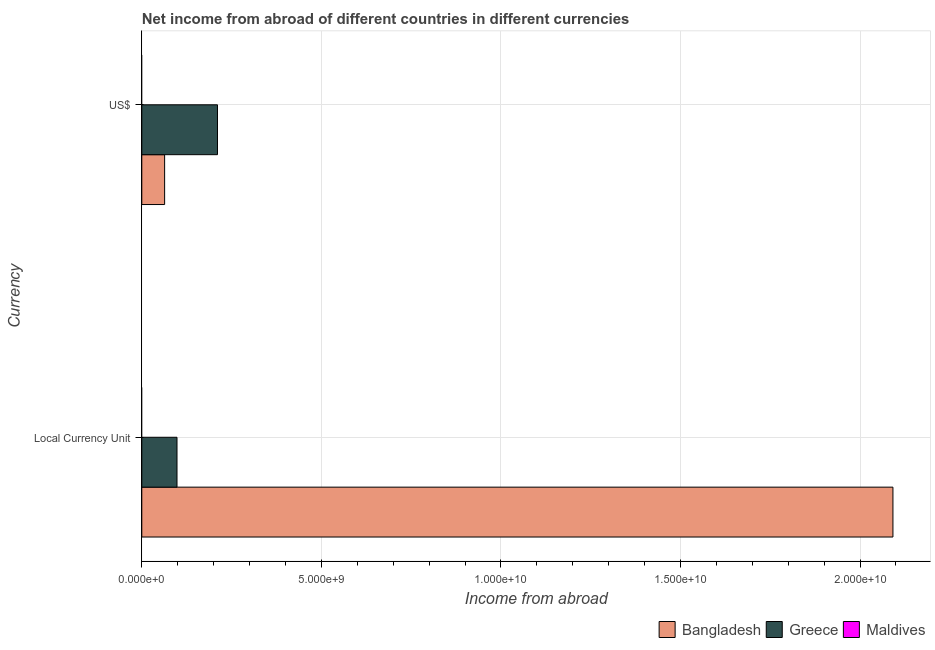How many groups of bars are there?
Your answer should be very brief. 2. Are the number of bars per tick equal to the number of legend labels?
Your response must be concise. No. Are the number of bars on each tick of the Y-axis equal?
Offer a terse response. Yes. How many bars are there on the 2nd tick from the bottom?
Ensure brevity in your answer.  2. What is the label of the 2nd group of bars from the top?
Provide a short and direct response. Local Currency Unit. What is the income from abroad in us$ in Bangladesh?
Make the answer very short. 6.36e+08. Across all countries, what is the maximum income from abroad in constant 2005 us$?
Your response must be concise. 2.09e+1. In which country was the income from abroad in us$ maximum?
Offer a terse response. Greece. What is the total income from abroad in constant 2005 us$ in the graph?
Your response must be concise. 2.19e+1. What is the difference between the income from abroad in constant 2005 us$ in Greece and that in Bangladesh?
Your answer should be compact. -1.99e+1. What is the difference between the income from abroad in constant 2005 us$ in Maldives and the income from abroad in us$ in Greece?
Ensure brevity in your answer.  -2.11e+09. What is the average income from abroad in constant 2005 us$ per country?
Provide a succinct answer. 7.30e+09. What is the difference between the income from abroad in constant 2005 us$ and income from abroad in us$ in Bangladesh?
Your response must be concise. 2.03e+1. What is the ratio of the income from abroad in us$ in Bangladesh to that in Greece?
Your answer should be very brief. 0.3. Is the income from abroad in constant 2005 us$ in Greece less than that in Bangladesh?
Give a very brief answer. Yes. How many bars are there?
Provide a short and direct response. 4. What is the difference between two consecutive major ticks on the X-axis?
Give a very brief answer. 5.00e+09. What is the title of the graph?
Your answer should be very brief. Net income from abroad of different countries in different currencies. Does "Canada" appear as one of the legend labels in the graph?
Your response must be concise. No. What is the label or title of the X-axis?
Ensure brevity in your answer.  Income from abroad. What is the label or title of the Y-axis?
Keep it short and to the point. Currency. What is the Income from abroad in Bangladesh in Local Currency Unit?
Your response must be concise. 2.09e+1. What is the Income from abroad of Greece in Local Currency Unit?
Offer a very short reply. 9.80e+08. What is the Income from abroad in Bangladesh in US$?
Keep it short and to the point. 6.36e+08. What is the Income from abroad in Greece in US$?
Your answer should be compact. 2.11e+09. What is the Income from abroad in Maldives in US$?
Give a very brief answer. 0. Across all Currency, what is the maximum Income from abroad in Bangladesh?
Keep it short and to the point. 2.09e+1. Across all Currency, what is the maximum Income from abroad of Greece?
Your answer should be very brief. 2.11e+09. Across all Currency, what is the minimum Income from abroad of Bangladesh?
Ensure brevity in your answer.  6.36e+08. Across all Currency, what is the minimum Income from abroad of Greece?
Provide a succinct answer. 9.80e+08. What is the total Income from abroad in Bangladesh in the graph?
Provide a short and direct response. 2.16e+1. What is the total Income from abroad of Greece in the graph?
Provide a short and direct response. 3.09e+09. What is the total Income from abroad of Maldives in the graph?
Your answer should be very brief. 0. What is the difference between the Income from abroad of Bangladesh in Local Currency Unit and that in US$?
Give a very brief answer. 2.03e+1. What is the difference between the Income from abroad of Greece in Local Currency Unit and that in US$?
Ensure brevity in your answer.  -1.13e+09. What is the difference between the Income from abroad in Bangladesh in Local Currency Unit and the Income from abroad in Greece in US$?
Offer a terse response. 1.88e+1. What is the average Income from abroad in Bangladesh per Currency?
Keep it short and to the point. 1.08e+1. What is the average Income from abroad of Greece per Currency?
Keep it short and to the point. 1.54e+09. What is the difference between the Income from abroad in Bangladesh and Income from abroad in Greece in Local Currency Unit?
Give a very brief answer. 1.99e+1. What is the difference between the Income from abroad in Bangladesh and Income from abroad in Greece in US$?
Your answer should be very brief. -1.47e+09. What is the ratio of the Income from abroad of Bangladesh in Local Currency Unit to that in US$?
Ensure brevity in your answer.  32.9. What is the ratio of the Income from abroad of Greece in Local Currency Unit to that in US$?
Offer a terse response. 0.47. What is the difference between the highest and the second highest Income from abroad in Bangladesh?
Keep it short and to the point. 2.03e+1. What is the difference between the highest and the second highest Income from abroad in Greece?
Your answer should be compact. 1.13e+09. What is the difference between the highest and the lowest Income from abroad of Bangladesh?
Your answer should be very brief. 2.03e+1. What is the difference between the highest and the lowest Income from abroad in Greece?
Your response must be concise. 1.13e+09. 